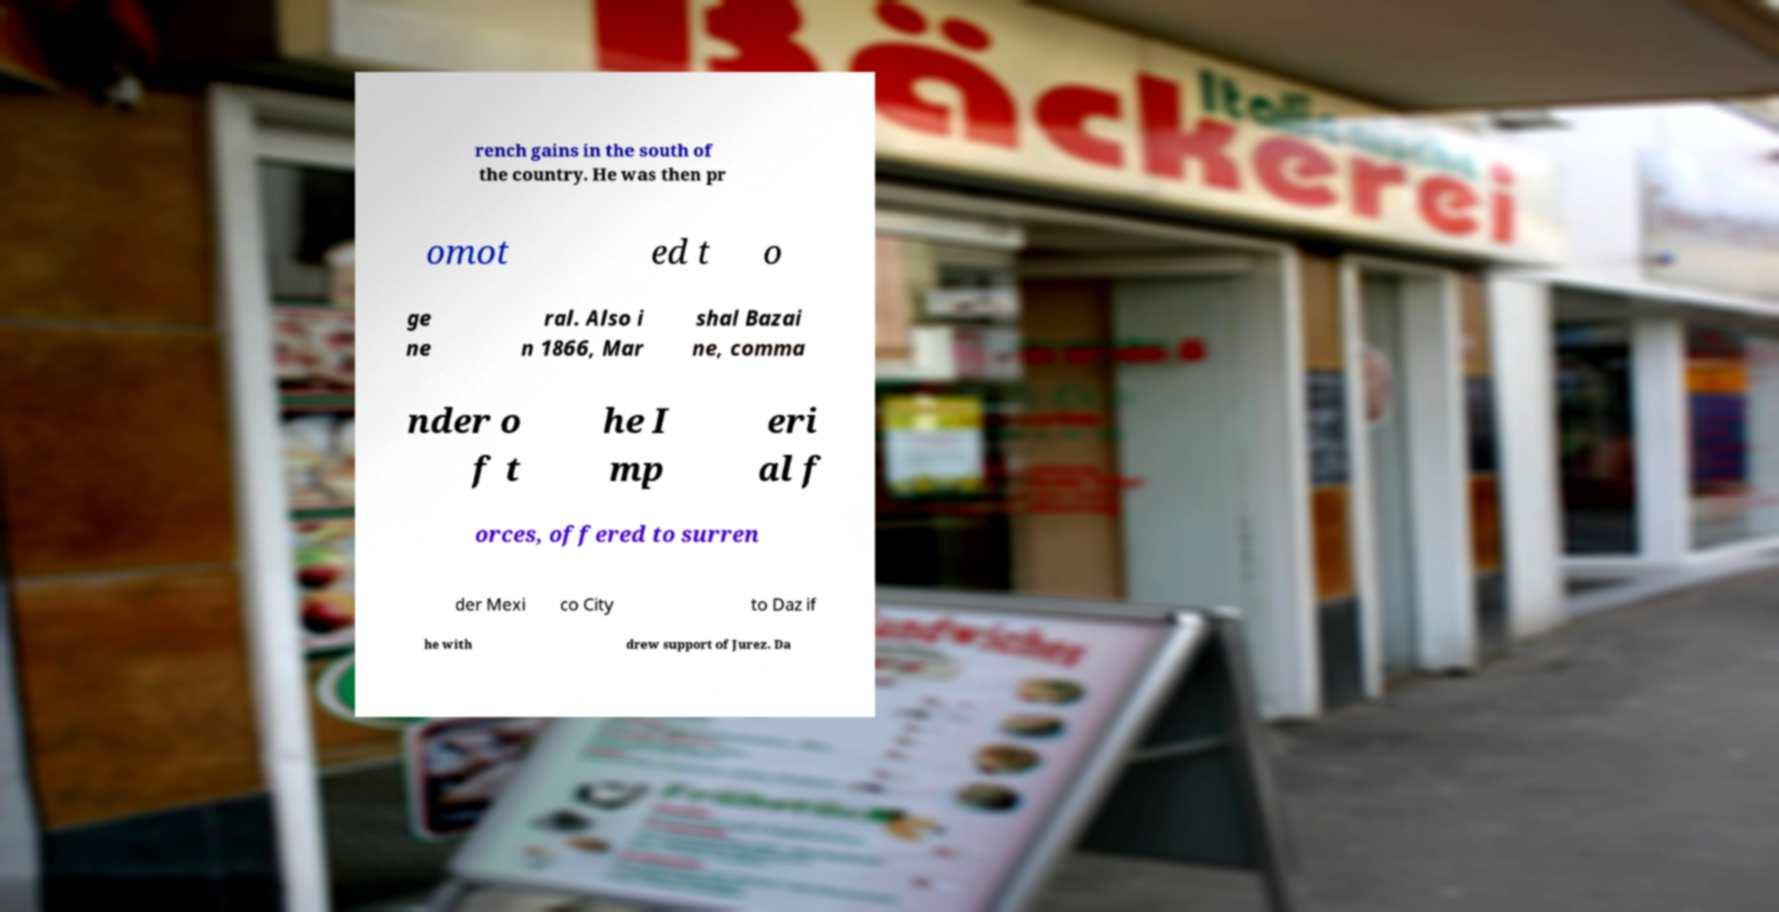Can you accurately transcribe the text from the provided image for me? rench gains in the south of the country. He was then pr omot ed t o ge ne ral. Also i n 1866, Mar shal Bazai ne, comma nder o f t he I mp eri al f orces, offered to surren der Mexi co City to Daz if he with drew support of Jurez. Da 